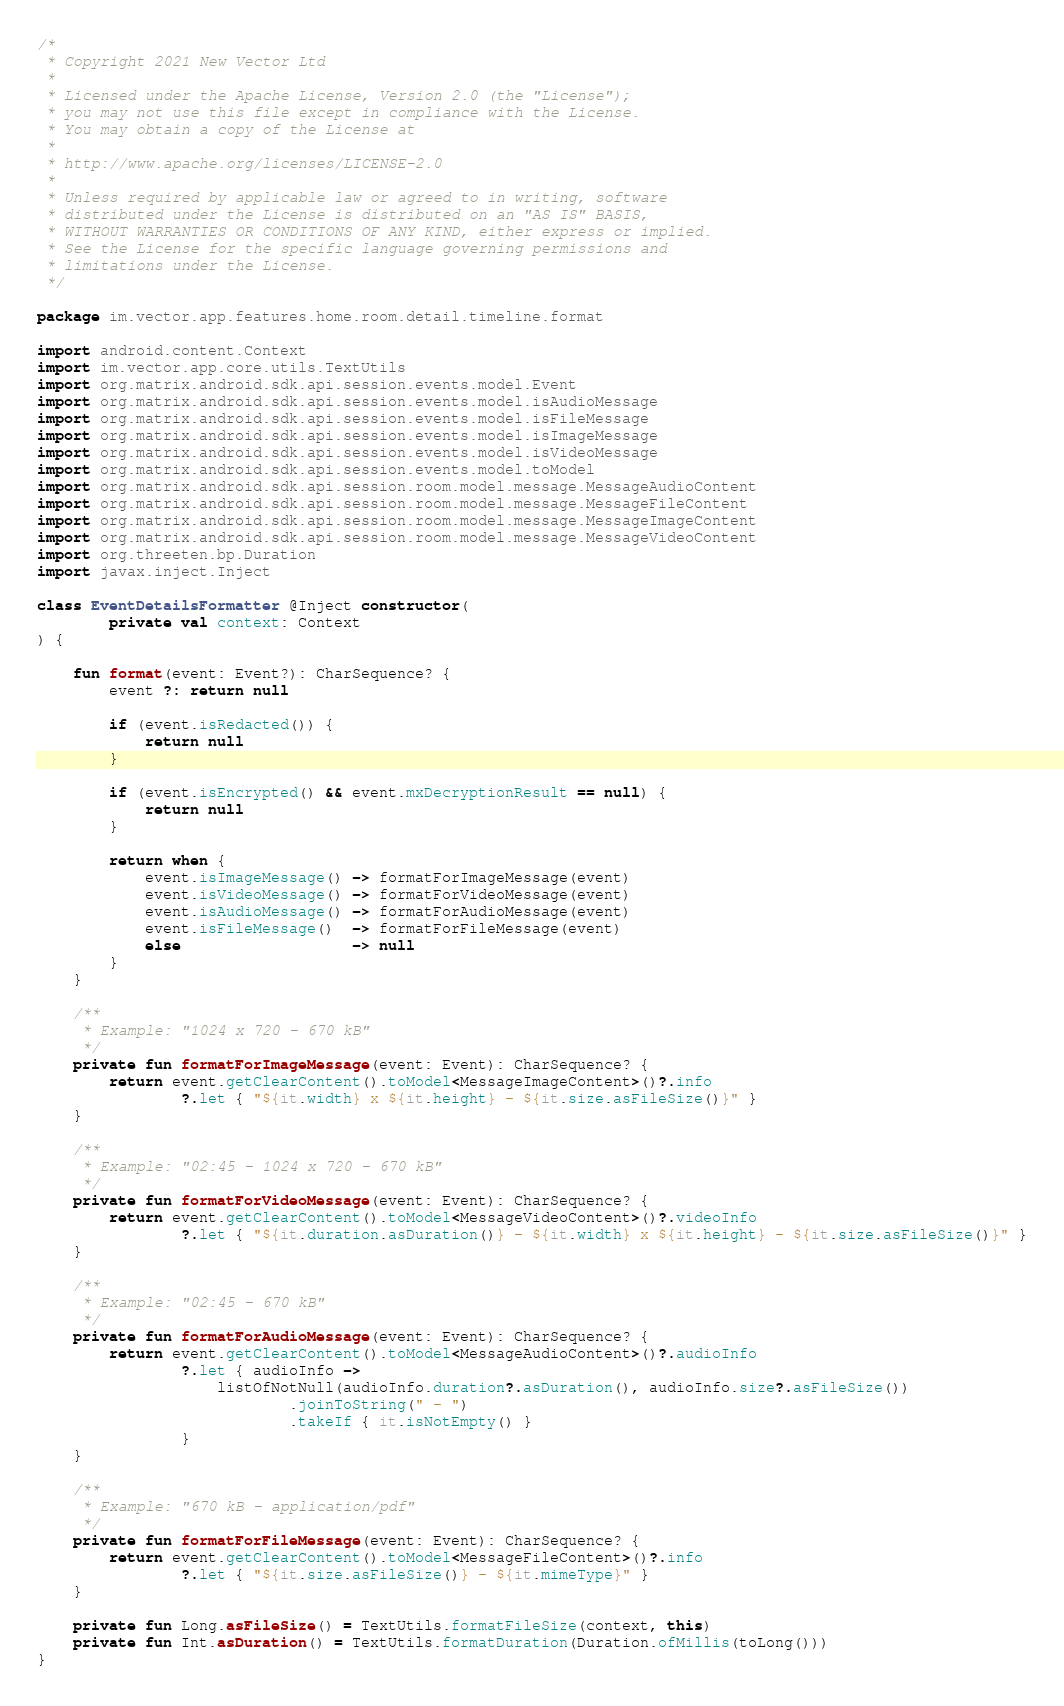Convert code to text. <code><loc_0><loc_0><loc_500><loc_500><_Kotlin_>/*
 * Copyright 2021 New Vector Ltd
 *
 * Licensed under the Apache License, Version 2.0 (the "License");
 * you may not use this file except in compliance with the License.
 * You may obtain a copy of the License at
 *
 * http://www.apache.org/licenses/LICENSE-2.0
 *
 * Unless required by applicable law or agreed to in writing, software
 * distributed under the License is distributed on an "AS IS" BASIS,
 * WITHOUT WARRANTIES OR CONDITIONS OF ANY KIND, either express or implied.
 * See the License for the specific language governing permissions and
 * limitations under the License.
 */

package im.vector.app.features.home.room.detail.timeline.format

import android.content.Context
import im.vector.app.core.utils.TextUtils
import org.matrix.android.sdk.api.session.events.model.Event
import org.matrix.android.sdk.api.session.events.model.isAudioMessage
import org.matrix.android.sdk.api.session.events.model.isFileMessage
import org.matrix.android.sdk.api.session.events.model.isImageMessage
import org.matrix.android.sdk.api.session.events.model.isVideoMessage
import org.matrix.android.sdk.api.session.events.model.toModel
import org.matrix.android.sdk.api.session.room.model.message.MessageAudioContent
import org.matrix.android.sdk.api.session.room.model.message.MessageFileContent
import org.matrix.android.sdk.api.session.room.model.message.MessageImageContent
import org.matrix.android.sdk.api.session.room.model.message.MessageVideoContent
import org.threeten.bp.Duration
import javax.inject.Inject

class EventDetailsFormatter @Inject constructor(
        private val context: Context
) {

    fun format(event: Event?): CharSequence? {
        event ?: return null

        if (event.isRedacted()) {
            return null
        }

        if (event.isEncrypted() && event.mxDecryptionResult == null) {
            return null
        }

        return when {
            event.isImageMessage() -> formatForImageMessage(event)
            event.isVideoMessage() -> formatForVideoMessage(event)
            event.isAudioMessage() -> formatForAudioMessage(event)
            event.isFileMessage()  -> formatForFileMessage(event)
            else                   -> null
        }
    }

    /**
     * Example: "1024 x 720 - 670 kB"
     */
    private fun formatForImageMessage(event: Event): CharSequence? {
        return event.getClearContent().toModel<MessageImageContent>()?.info
                ?.let { "${it.width} x ${it.height} - ${it.size.asFileSize()}" }
    }

    /**
     * Example: "02:45 - 1024 x 720 - 670 kB"
     */
    private fun formatForVideoMessage(event: Event): CharSequence? {
        return event.getClearContent().toModel<MessageVideoContent>()?.videoInfo
                ?.let { "${it.duration.asDuration()} - ${it.width} x ${it.height} - ${it.size.asFileSize()}" }
    }

    /**
     * Example: "02:45 - 670 kB"
     */
    private fun formatForAudioMessage(event: Event): CharSequence? {
        return event.getClearContent().toModel<MessageAudioContent>()?.audioInfo
                ?.let { audioInfo ->
                    listOfNotNull(audioInfo.duration?.asDuration(), audioInfo.size?.asFileSize())
                            .joinToString(" - ")
                            .takeIf { it.isNotEmpty() }
                }
    }

    /**
     * Example: "670 kB - application/pdf"
     */
    private fun formatForFileMessage(event: Event): CharSequence? {
        return event.getClearContent().toModel<MessageFileContent>()?.info
                ?.let { "${it.size.asFileSize()} - ${it.mimeType}" }
    }

    private fun Long.asFileSize() = TextUtils.formatFileSize(context, this)
    private fun Int.asDuration() = TextUtils.formatDuration(Duration.ofMillis(toLong()))
}
</code> 